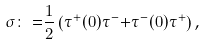Convert formula to latex. <formula><loc_0><loc_0><loc_500><loc_500>\sigma { \colon = } \frac { 1 } { 2 } \left ( \tau ^ { + } ( 0 ) \tau ^ { - } { + } \tau ^ { - } ( 0 ) \tau ^ { + } \right ) ,</formula> 